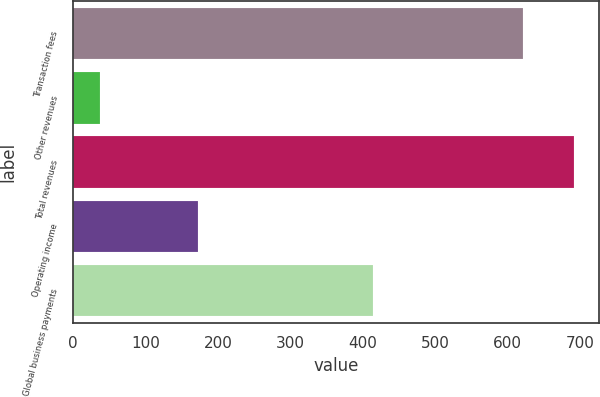Convert chart. <chart><loc_0><loc_0><loc_500><loc_500><bar_chart><fcel>Transaction fees<fcel>Other revenues<fcel>Total revenues<fcel>Operating income<fcel>Global business payments<nl><fcel>621.9<fcel>36.6<fcel>691.7<fcel>171.9<fcel>414.8<nl></chart> 